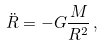Convert formula to latex. <formula><loc_0><loc_0><loc_500><loc_500>\ddot { R } = - G \frac { M } { R ^ { 2 } } \, ,</formula> 